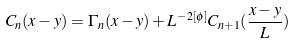<formula> <loc_0><loc_0><loc_500><loc_500>C _ { n } ( x - y ) = \Gamma _ { n } ( x - y ) + L ^ { - 2 [ \phi ] } C _ { n + 1 } ( \frac { x - y } { L } )</formula> 